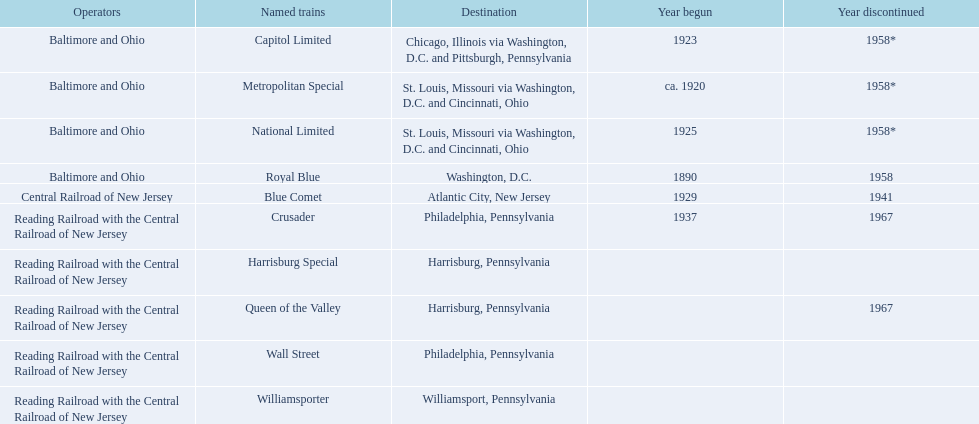What were all the places? Chicago, Illinois via Washington, D.C. and Pittsburgh, Pennsylvania, St. Louis, Missouri via Washington, D.C. and Cincinnati, Ohio, St. Louis, Missouri via Washington, D.C. and Cincinnati, Ohio, Washington, D.C., Atlantic City, New Jersey, Philadelphia, Pennsylvania, Harrisburg, Pennsylvania, Harrisburg, Pennsylvania, Philadelphia, Pennsylvania, Williamsport, Pennsylvania. And what were the names of the trains? Capitol Limited, Metropolitan Special, National Limited, Royal Blue, Blue Comet, Crusader, Harrisburg Special, Queen of the Valley, Wall Street, Williamsporter. Of those, and along with wall street, which train traveled to philadelphia, pennsylvania? Crusader. 